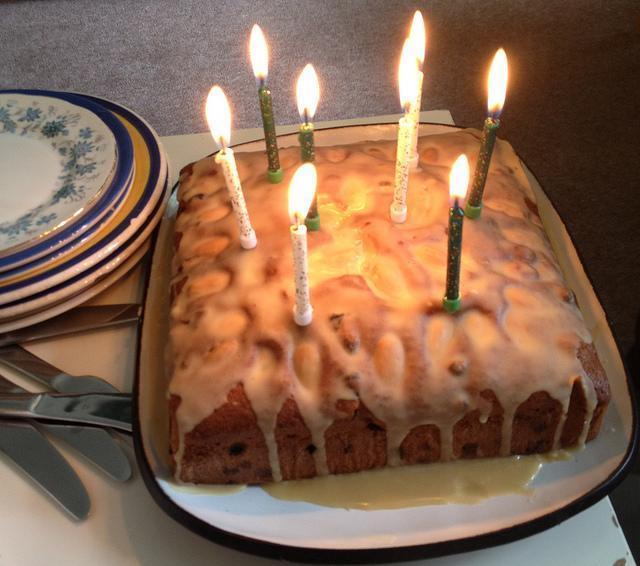How many candles are there?
Give a very brief answer. 8. How many knives are there?
Give a very brief answer. 5. 